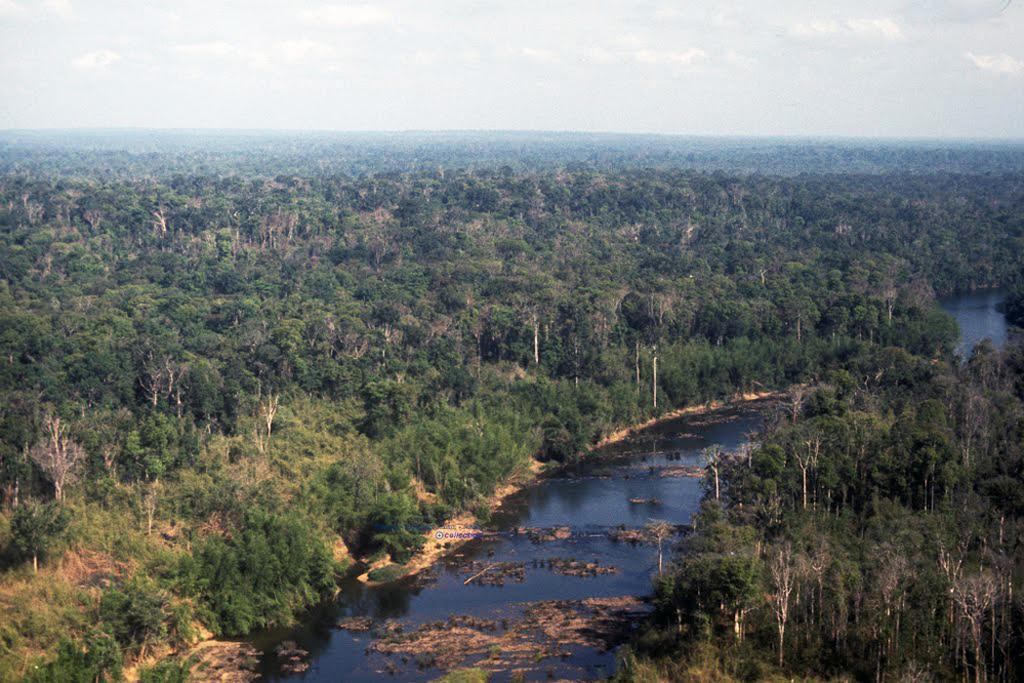What can be seen in the background of the image? The sky with clouds is visible in the background of the image. What type of natural environment is depicted in the image? The image contains greenery and trees. What is the water element in the image? Water is present in the image. What type of metal can be seen in the image? There is no metal present in the image; it features natural elements such as sky, greenery, trees, and water. 